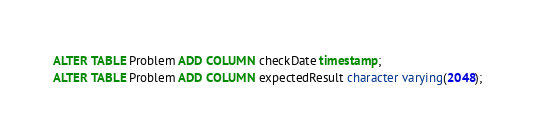<code> <loc_0><loc_0><loc_500><loc_500><_SQL_>ALTER TABLE Problem ADD COLUMN checkDate timestamp;
ALTER TABLE Problem ADD COLUMN expectedResult character varying(2048);
</code> 